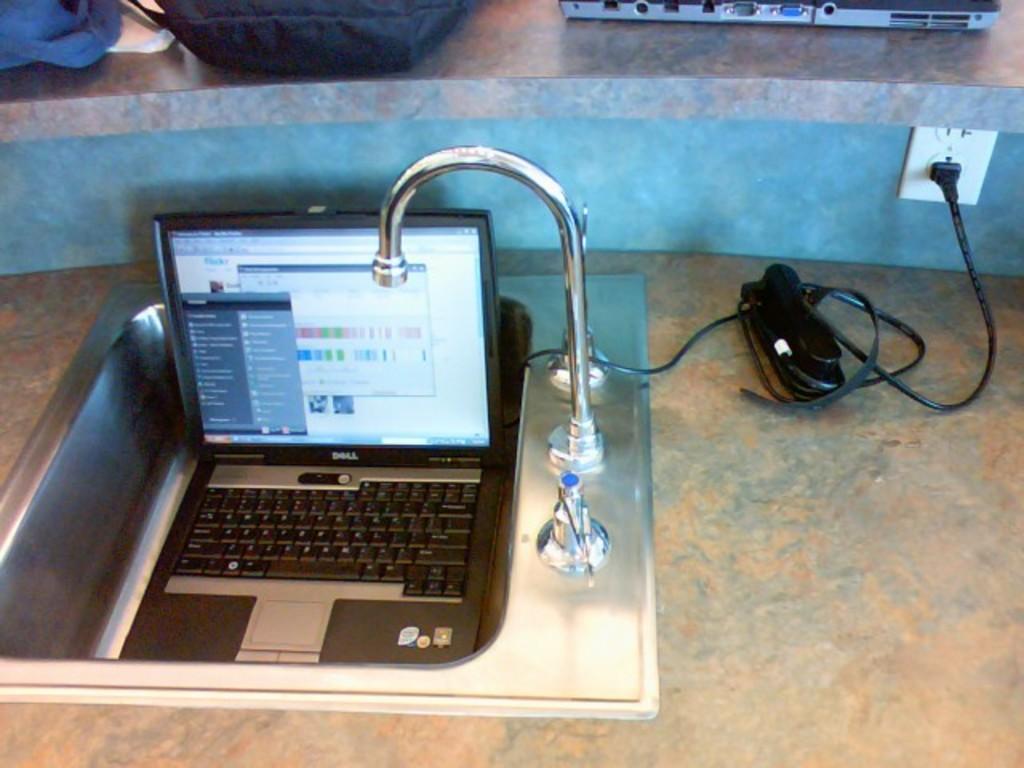How would you summarize this image in a sentence or two? In this image there is a sink, in that sink there is a laptop and a charger connected to a plug. 